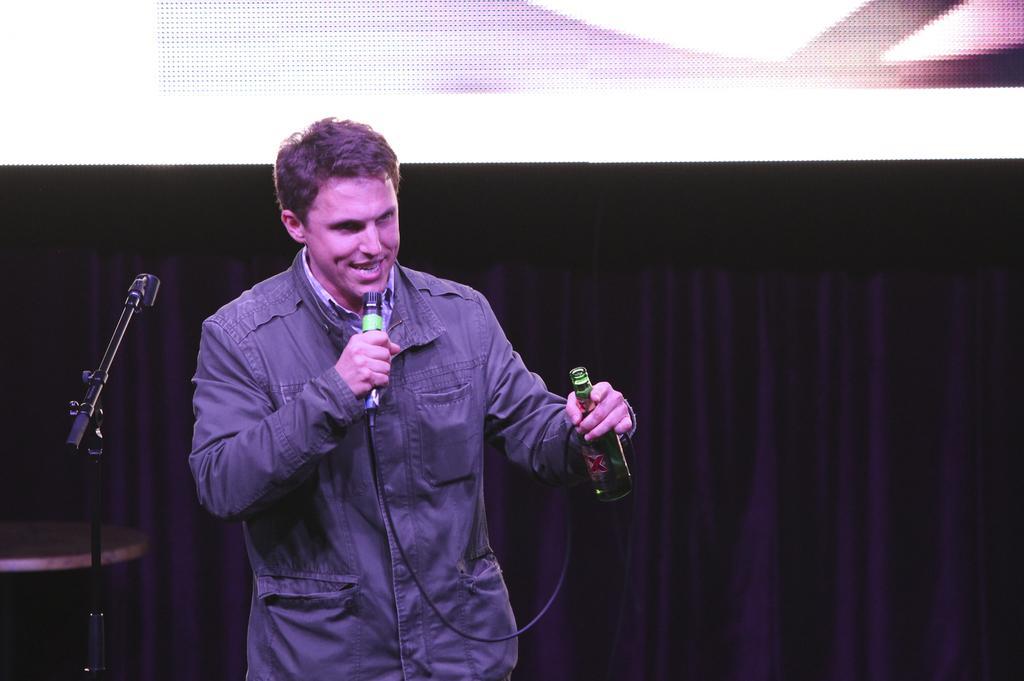How would you summarize this image in a sentence or two? Man in the middle of the picture wearing black jacket is holding a microphone in his hands and he is speaking on it. On the other hand, he is holding glass bottle. Beside him, we see microphone and behind him, we see a sheet which is black in color and on top of the picture, we see projector screen. 